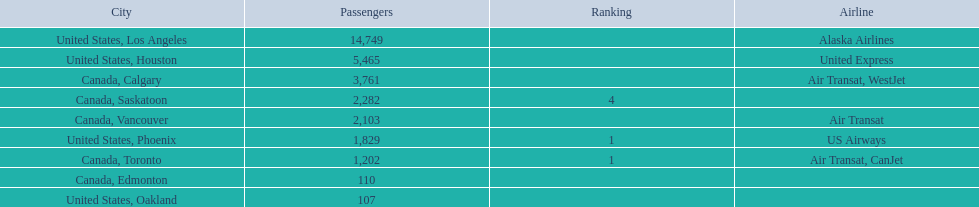What are the cities that are associated with the playa de oro international airport? United States, Los Angeles, United States, Houston, Canada, Calgary, Canada, Saskatoon, Canada, Vancouver, United States, Phoenix, Canada, Toronto, Canada, Edmonton, United States, Oakland. What is uniteed states, los angeles passenger count? 14,749. What other cities passenger count would lead to 19,000 roughly when combined with previous los angeles? Canada, Calgary. 